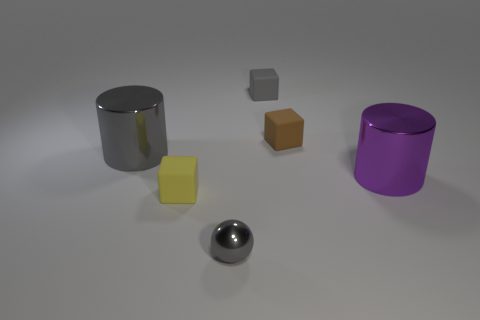What number of other balls have the same color as the small shiny sphere?
Your response must be concise. 0. What is the material of the gray object that is in front of the big gray cylinder?
Keep it short and to the point. Metal. How many large things are gray shiny spheres or gray cylinders?
Your answer should be very brief. 1. What material is the small cube that is the same color as the shiny sphere?
Provide a short and direct response. Rubber. Is there a big gray object made of the same material as the gray sphere?
Offer a terse response. Yes. There is a cylinder on the right side of the gray matte thing; is its size the same as the yellow object?
Ensure brevity in your answer.  No. There is a gray metallic thing that is to the left of the small gray object that is in front of the brown rubber block; is there a small yellow thing that is in front of it?
Offer a very short reply. Yes. How many matte things are either small red cylinders or tiny cubes?
Keep it short and to the point. 3. How many other objects are the same shape as the purple object?
Offer a terse response. 1. Are there more small gray matte spheres than large purple cylinders?
Provide a succinct answer. No. 